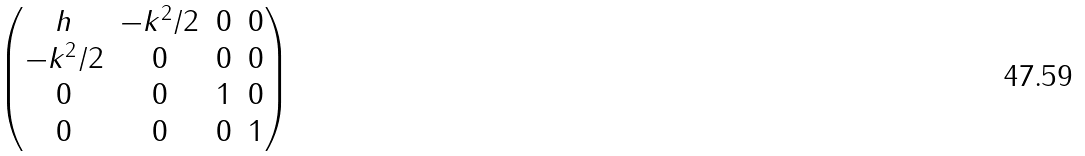<formula> <loc_0><loc_0><loc_500><loc_500>\begin{pmatrix} h & - k ^ { 2 } / 2 & 0 & 0 \\ - k ^ { 2 } / 2 & 0 & 0 & 0 \\ 0 & 0 & 1 & 0 \\ 0 & 0 & 0 & 1 \end{pmatrix}</formula> 